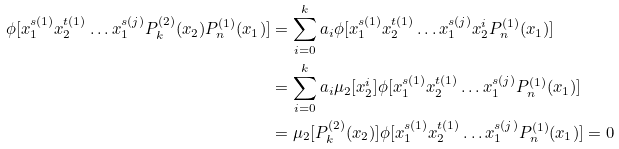<formula> <loc_0><loc_0><loc_500><loc_500>\phi [ x _ { 1 } ^ { s ( 1 ) } x _ { 2 } ^ { t ( 1 ) } \dots x _ { 1 } ^ { s ( j ) } P ^ { ( 2 ) } _ { k } ( x _ { 2 } ) P ^ { ( 1 ) } _ { n } ( x _ { 1 } ) ] & = \sum _ { i = 0 } ^ { k } a _ { i } \phi [ x _ { 1 } ^ { s ( 1 ) } x _ { 2 } ^ { t ( 1 ) } \dots x _ { 1 } ^ { s ( j ) } x _ { 2 } ^ { i } P ^ { ( 1 ) } _ { n } ( x _ { 1 } ) ] \\ & = \sum _ { i = 0 } ^ { k } a _ { i } \mu _ { 2 } [ x _ { 2 } ^ { i } ] \phi [ x _ { 1 } ^ { s ( 1 ) } x _ { 2 } ^ { t ( 1 ) } \dots x _ { 1 } ^ { s ( j ) } P ^ { ( 1 ) } _ { n } ( x _ { 1 } ) ] \\ & = \mu _ { 2 } [ P ^ { ( 2 ) } _ { k } ( x _ { 2 } ) ] \phi [ x _ { 1 } ^ { s ( 1 ) } x _ { 2 } ^ { t ( 1 ) } \dots x _ { 1 } ^ { s ( j ) } P ^ { ( 1 ) } _ { n } ( x _ { 1 } ) ] = 0</formula> 